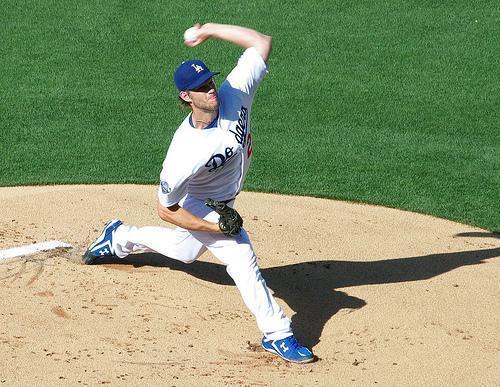How many men are there?
Give a very brief answer. 1. 